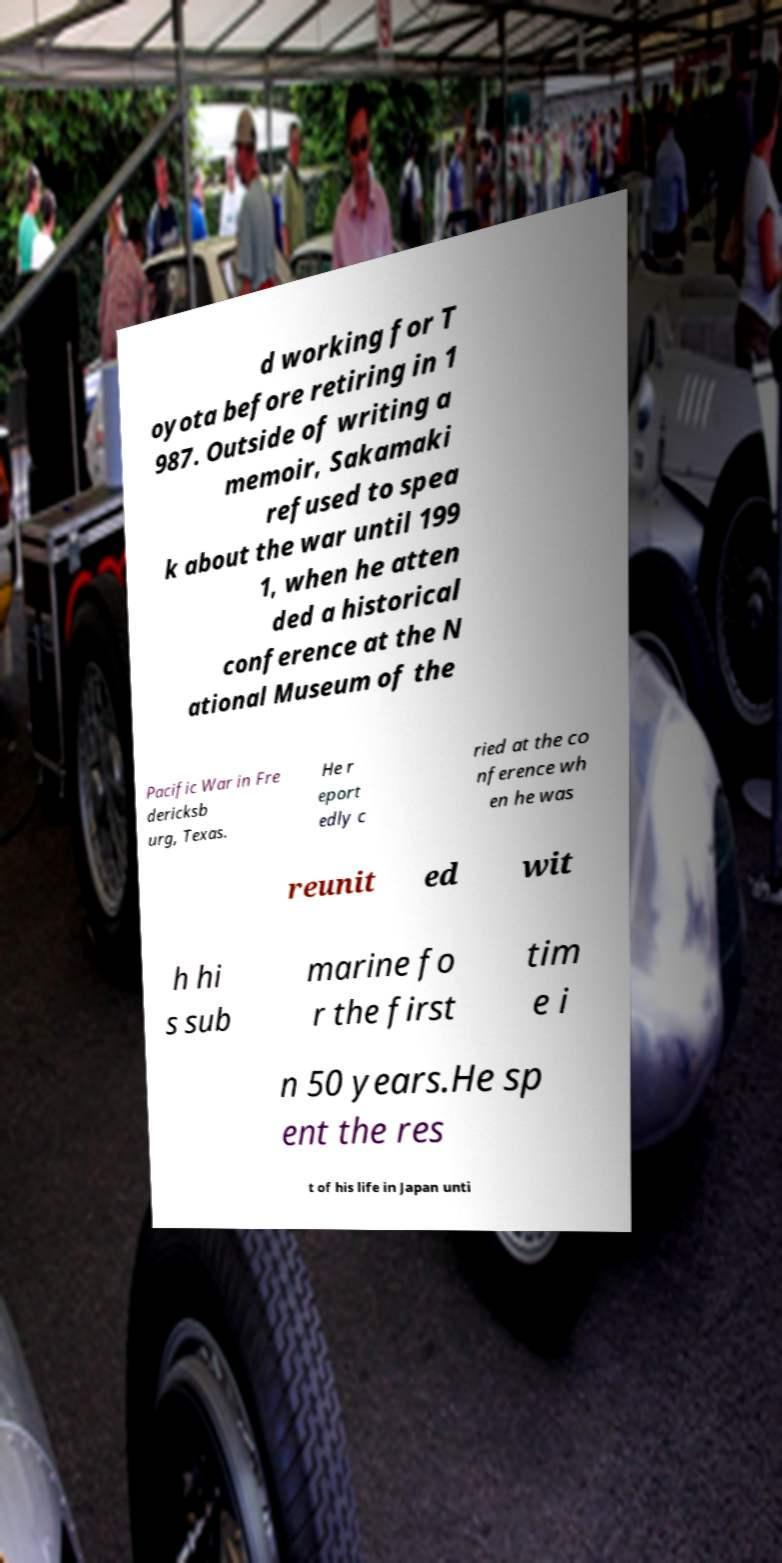Please read and relay the text visible in this image. What does it say? d working for T oyota before retiring in 1 987. Outside of writing a memoir, Sakamaki refused to spea k about the war until 199 1, when he atten ded a historical conference at the N ational Museum of the Pacific War in Fre dericksb urg, Texas. He r eport edly c ried at the co nference wh en he was reunit ed wit h hi s sub marine fo r the first tim e i n 50 years.He sp ent the res t of his life in Japan unti 